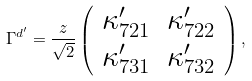Convert formula to latex. <formula><loc_0><loc_0><loc_500><loc_500>\Gamma ^ { d ^ { \prime } } = \frac { z } { \sqrt { 2 } } \left ( \begin{array} { c c } \kappa ^ { \prime } _ { 7 2 1 } & \kappa ^ { \prime } _ { 7 2 2 } \\ \kappa ^ { \prime } _ { 7 3 1 } & \kappa ^ { \prime } _ { 7 3 2 } \end{array} \right ) ,</formula> 